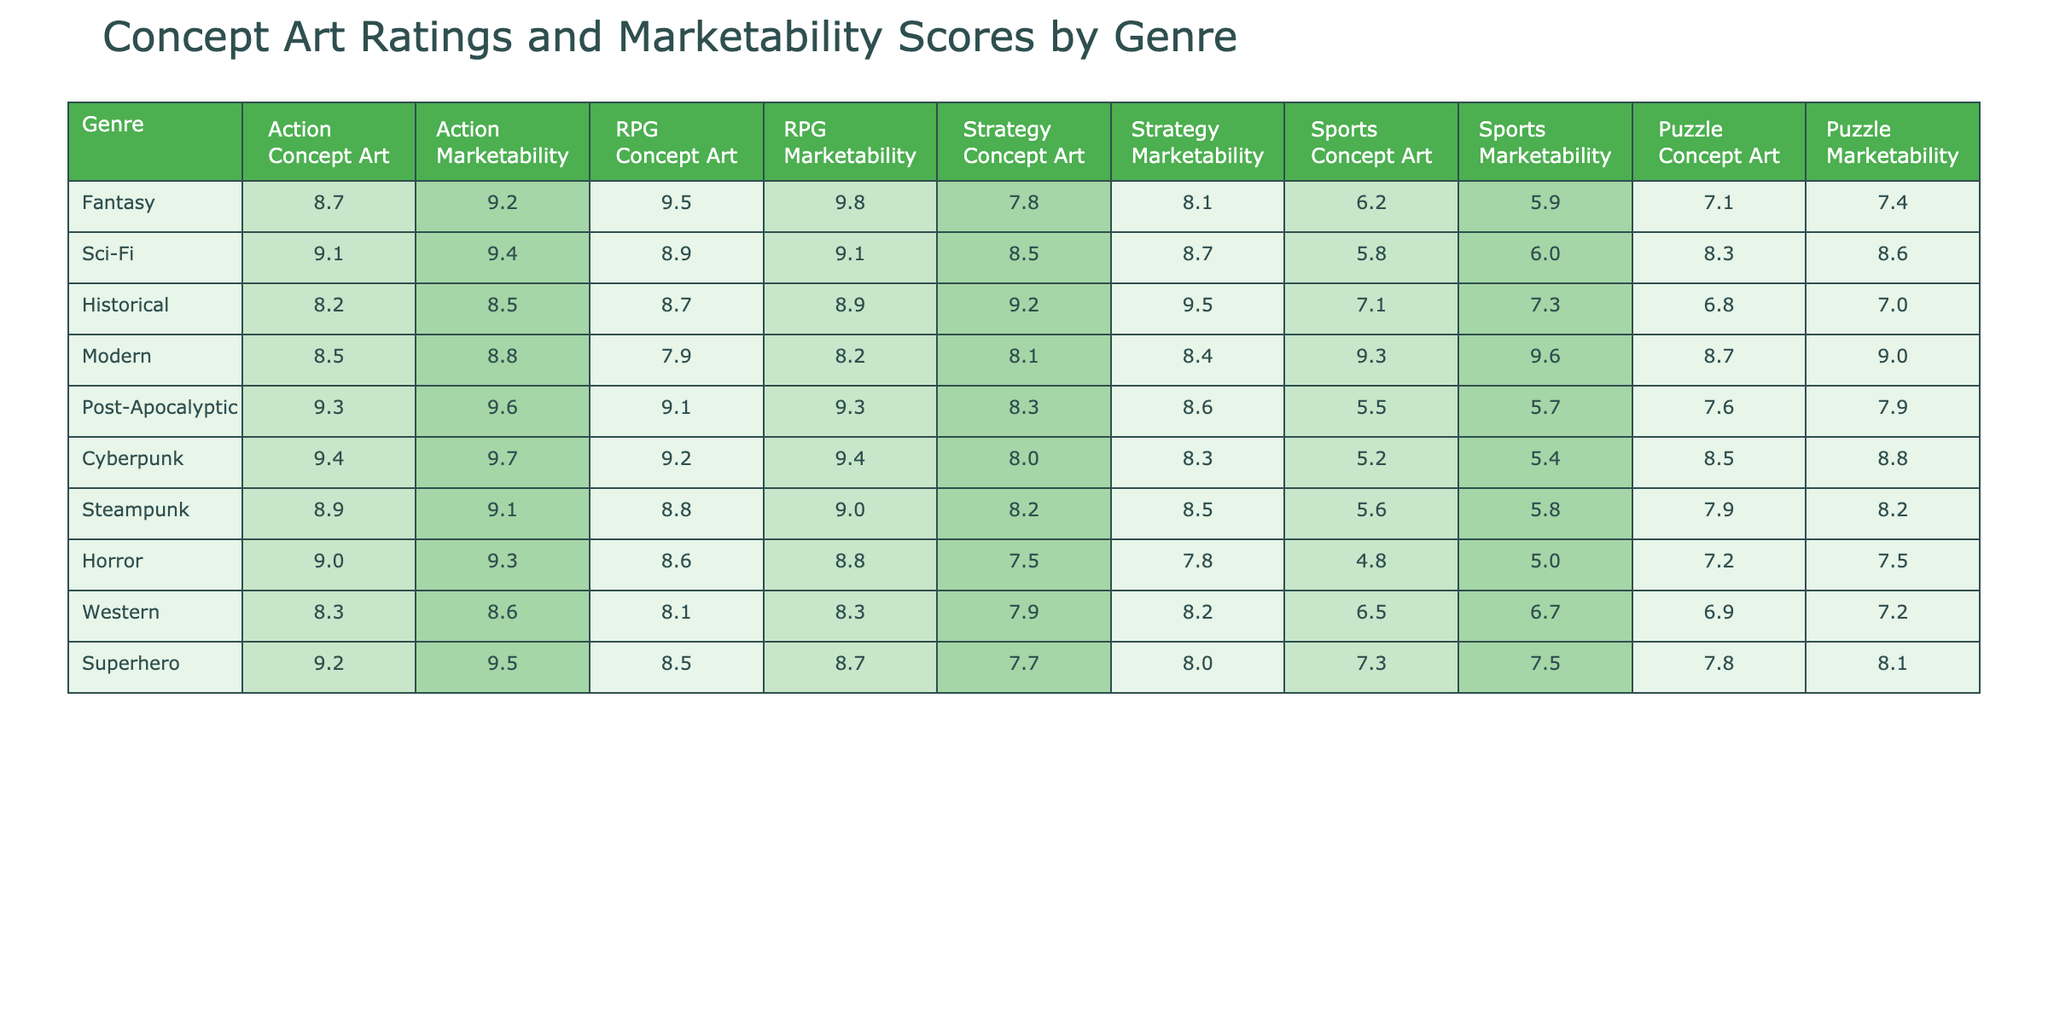What is the highest Action Concept Art Rating? By looking at the table, the highest Action Concept Art Rating is in the Cyberpunk genre with a rating of 9.4.
Answer: 9.4 Which genre has the lowest Marketability score for Sports? The lowest Marketability score for Sports is in the Horror genre, which has a score of 5.0.
Answer: 5.0 What is the average Concept Art Rating for the RPG genre across all listed game styles? The RPG Concept Art Ratings are 9.5, 8.9, 8.7, 8.1, and 8.5. Summing these gives 43.7 and dividing by 5 gives an average of 8.74.
Answer: 8.74 Is the Marketability score for Historical games higher than the Marketability score for Sports games? The Historical Marketability score is 7.3, while the Sports Marketability score is 7.3 as well, thus they are equal and one is not higher than the other.
Answer: No Which genre has the highest average Concept Art Rating across all categories? To find this, we need to sum the Concept Art Ratings for each genre. The calculations yield Fantasy: 8.7+9.5+7.8+6.2+7.1=39.3, Sci-Fi: 9.1+8.9+8.5+5.8+8.3=40.6, Historical: 8.2+8.7+9.2+7.1+6.8=40.0, Modern: 8.5+7.9+8.1+9.3+8.7=42.5, Post-Apocalyptic: 9.3+9.1+8.3+5.5+7.6=39.8, Cyberpunk: 9.4+9.2+8.0+5.2+8.5=40.3, Steampunk: 8.9+8.8+8.2+5.6+7.9=39.4, Horror: 9.0+8.6+7.5+4.8+7.2=37.1, Western: 8.3+8.1+7.9+6.5+6.9=37.7, Superhero: 9.2+8.5+7.7+7.3+7.8=40.5. The highest average is for the Modern genre with a sum of 42.5.
Answer: Modern What is the difference between the highest and lowest Concept Art Rating for the Strategy genre? The highest Strategy Concept Art Rating is 9.2 (Historical), and the lowest is 7.5 (Horror). The difference is 9.2 - 7.5 = 1.7.
Answer: 1.7 Is there any genre where the Concept Art Rating is equal to its Marketability score? By examining the table, we can see that the Action genre, with a rating of 9.2 and a marketability of 9.2 for Fantasy, is one such instance where they are equal.
Answer: Yes Which genre shows the biggest gap between Concept Art Rating and Marketability score in the Horror category? The Horror genre has a Concept Art Rating of 9.0 and a Marketability score of 8.8. The gap is 9.0 - 8.8 = 0.2.
Answer: 0.2 Among all genres, which one has the lowest Concept Art Rating in the Sports category? The lowest Concept Art Rating for Sports is in the Horror genre at 4.8.
Answer: 4.8 